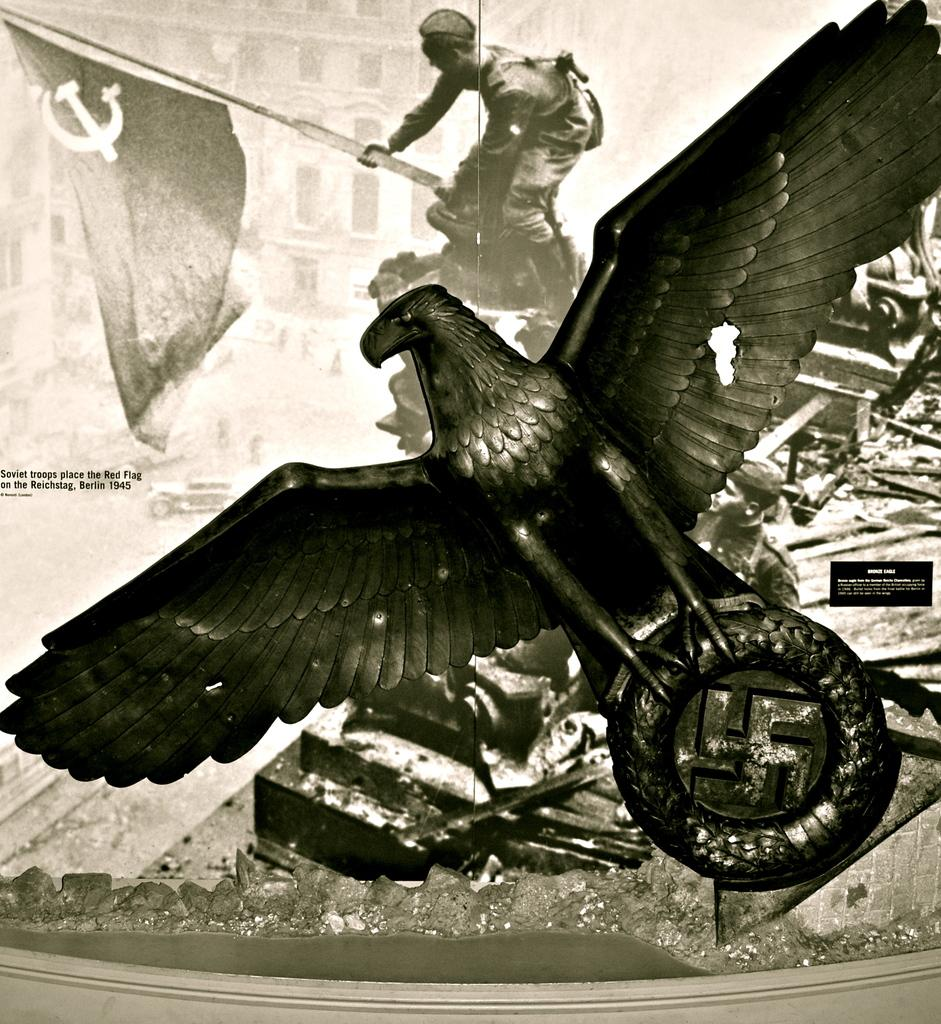What is the main subject of the image? The main subject of the image is a black and white picture of an eagle statue. Can you describe any other elements in the image? Yes, there is a photo in the background of the image. What is happening in the photo in the background? The photo in the background shows a person holding a flag in his hand. Where is the zoo located in the image? There is no zoo present in the image. What type of air is visible in the image? The image does not show any air; it contains a black and white picture of an eagle statue and a photo in the background. 